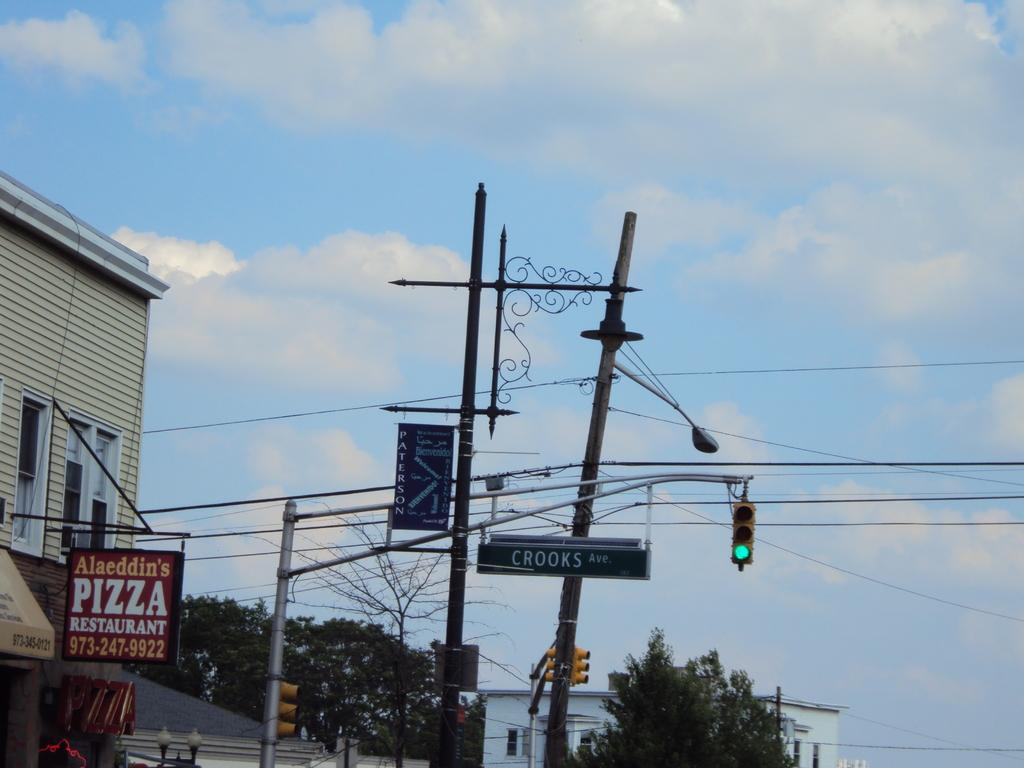What type of structures can be seen in the image? There are buildings in the image. What else can be seen in the image besides buildings? There are poles, wires, trees, lights, traffic signals, and boards in the image. What is the purpose of the poles in the image? The poles are likely used to support the wires and traffic signals. What is visible in the background of the image? The sky is visible in the background of the image. What type of metal coil can be seen in the image? There is no metal coil present in the image. How can the traffic signals be pulled to change their color? The traffic signals in the image are not designed to be pulled; they are controlled electronically. 